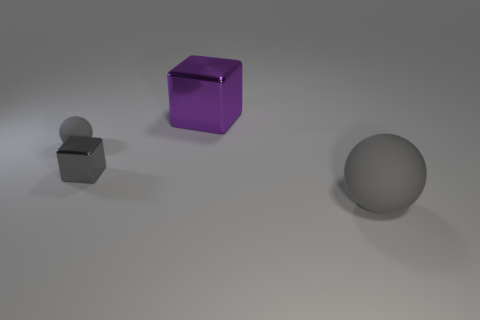What size is the other shiny object that is the same shape as the gray shiny object? The shiny object of the same shape as the gray object is significantly larger in size. Specifically, the purple cube appears to be about twice the size of its smaller, gray counterpart. 